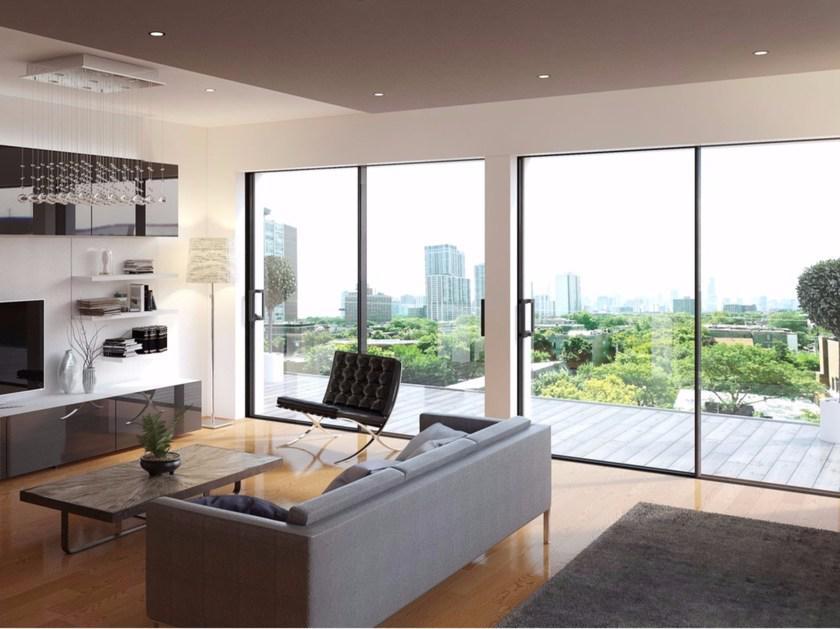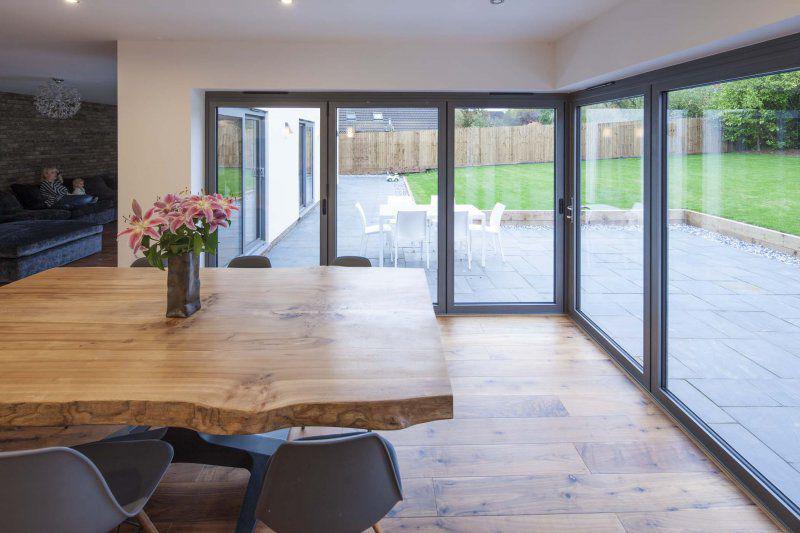The first image is the image on the left, the second image is the image on the right. Assess this claim about the two images: "The doors are open in both images.". Correct or not? Answer yes or no. No. 